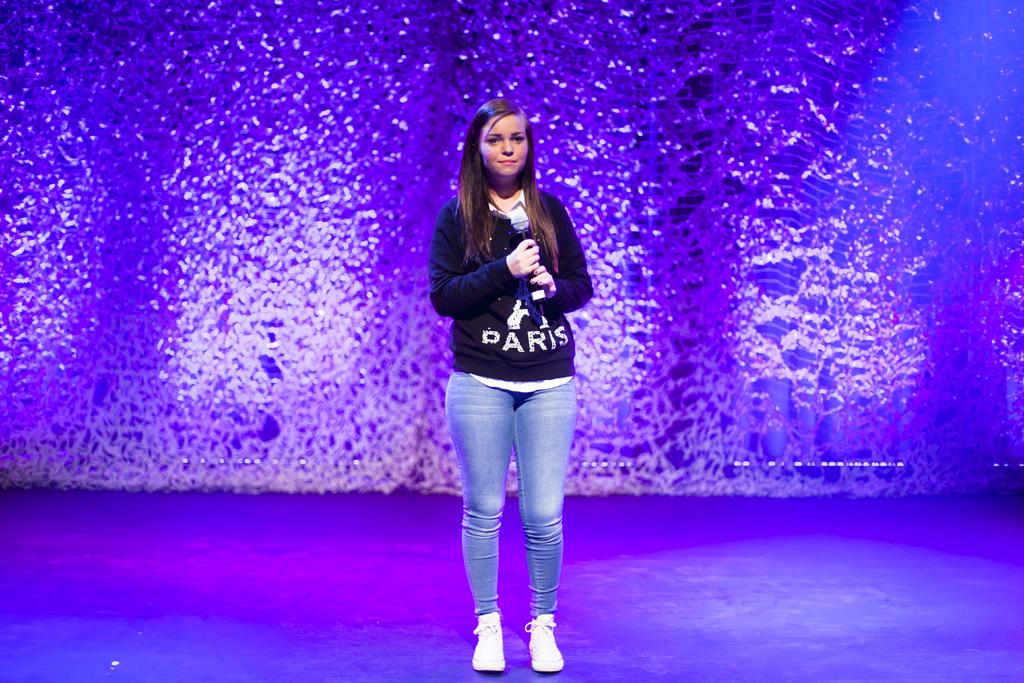Who is the main subject in the image? There is a girl in the image. What is the girl doing in the image? The girl is standing and holding a microphone in her hand. What can be seen in the background of the image? There is lighting visible in the background of the image. How does the sand affect the girl's performance in the image? There is no sand present in the image, so it cannot affect the girl's performance. 